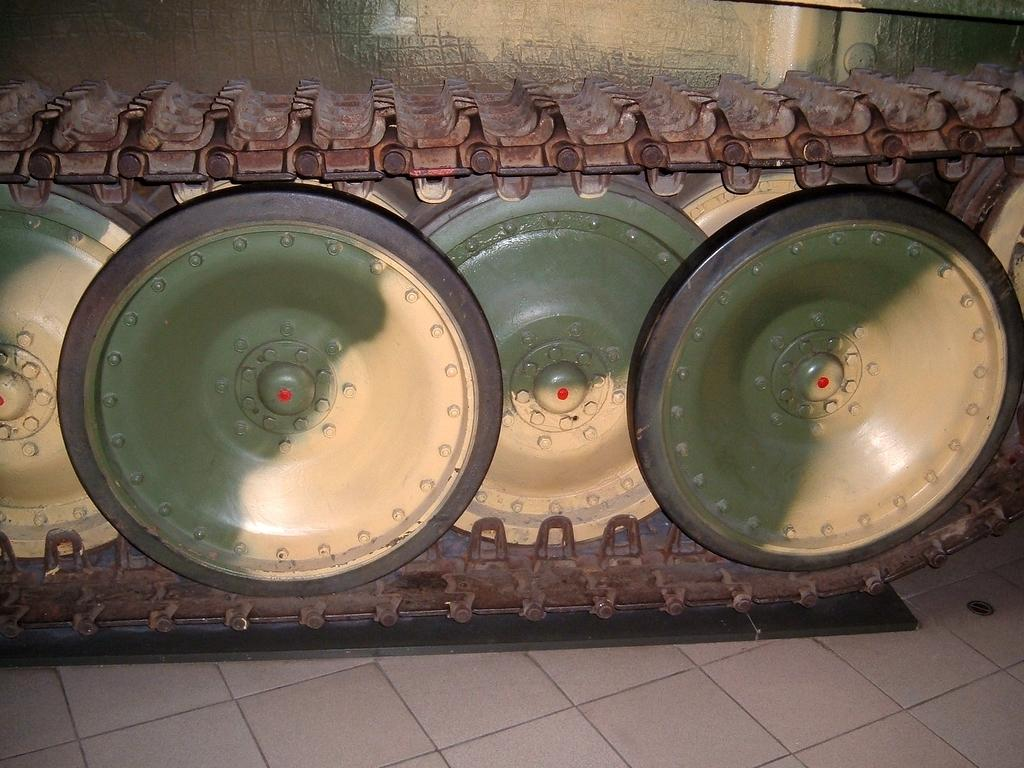What type of vehicle is associated with the wheels in the image? The wheels in the image belong to a tanker. What type of flooring is visible at the bottom of the image? There are tiles at the bottom of the image. How many holes can be seen in the image? There are no holes visible in the image. What type of land is depicted in the image? The image does not depict any land; it only shows the wheels of a tanker and tiles at the bottom. 